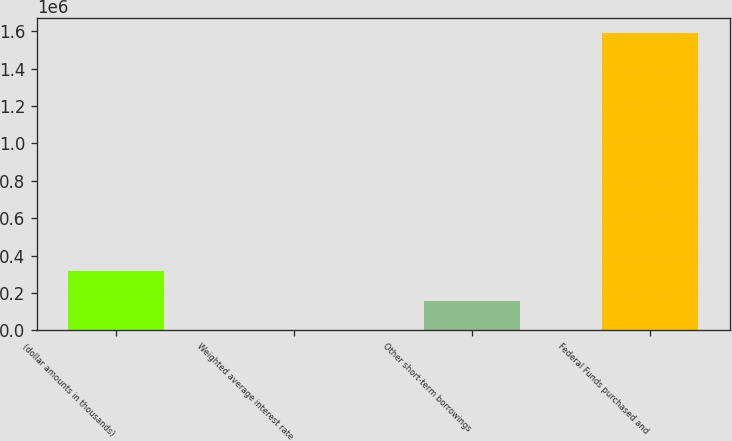Convert chart to OTSL. <chart><loc_0><loc_0><loc_500><loc_500><bar_chart><fcel>(dollar amounts in thousands)<fcel>Weighted average interest rate<fcel>Other short-term borrowings<fcel>Federal Funds purchased and<nl><fcel>318017<fcel>0.15<fcel>159008<fcel>1.59008e+06<nl></chart> 